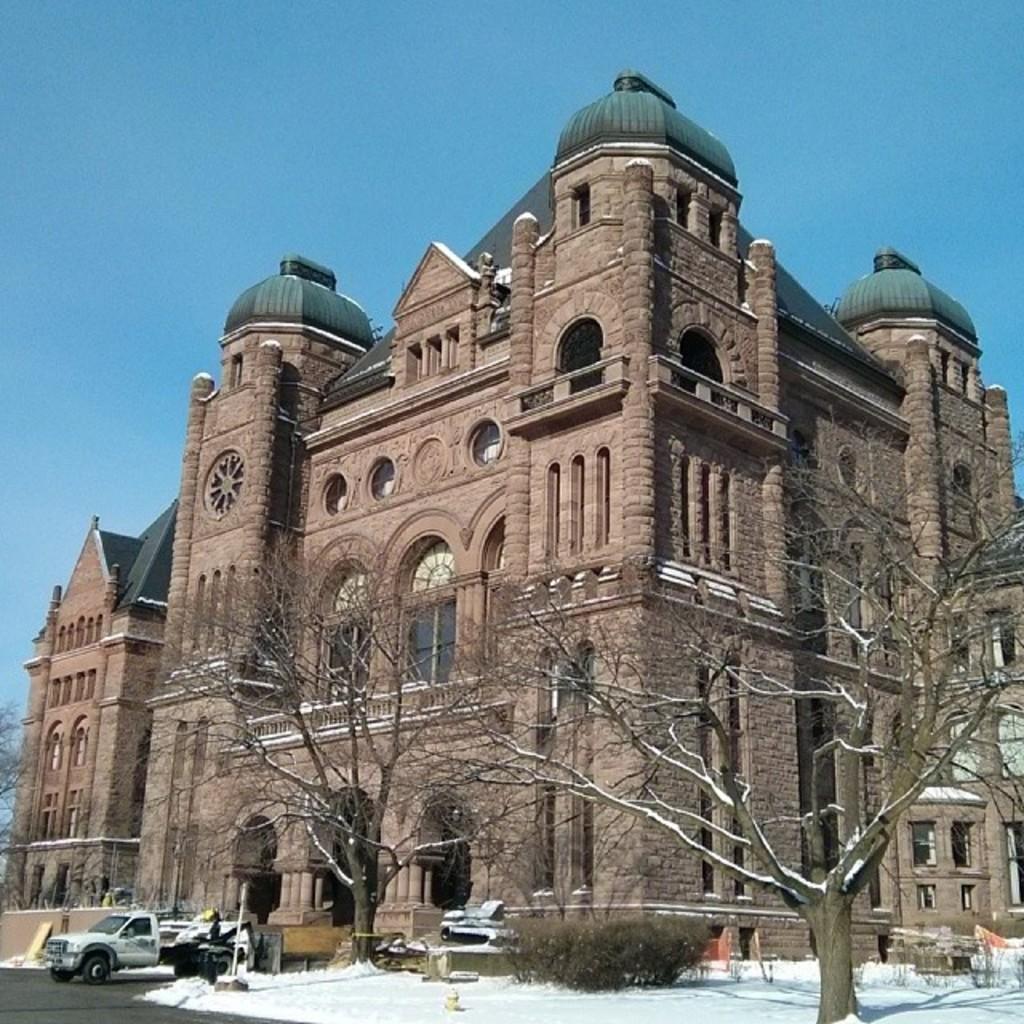In one or two sentences, can you explain what this image depicts? In the image I can see a building to which there are some windows, arches and also I can see some cars, trees and some snow on the floor. 